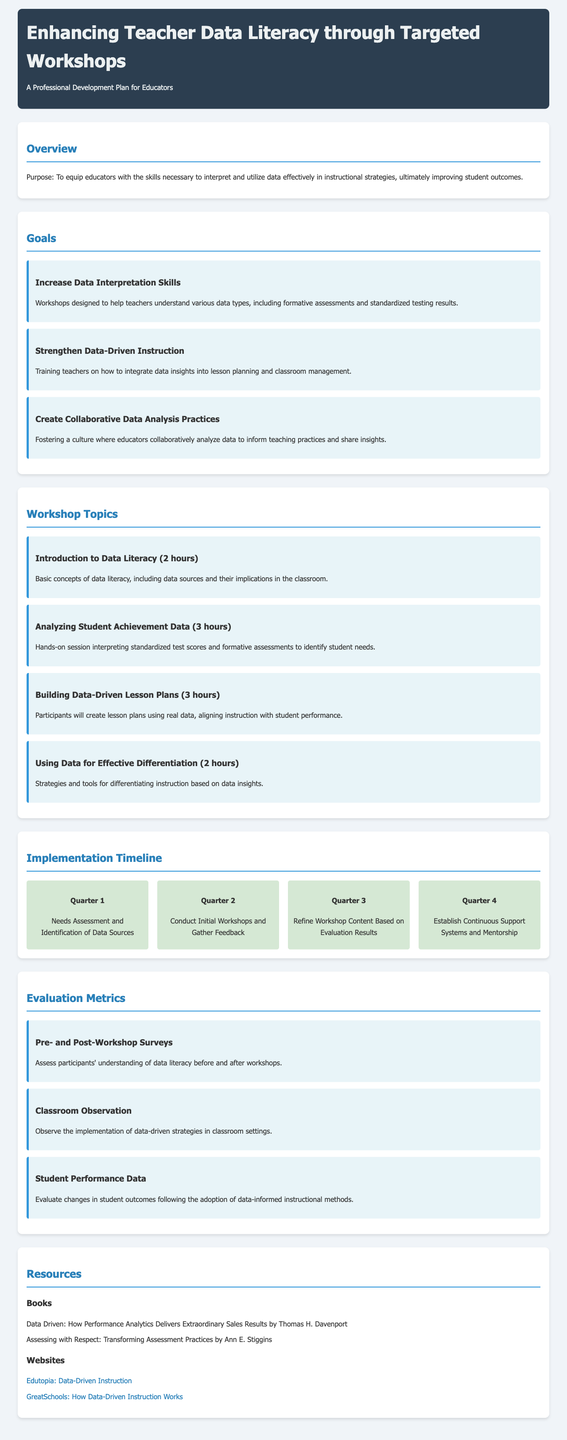What is the purpose of the manual? The purpose is to equip educators with the skills necessary to interpret and utilize data effectively in instructional strategies, ultimately improving student outcomes.
Answer: To equip educators with data skills How many hours is the "Analyzing Student Achievement Data" workshop? The workshop duration is specified in the document, with "Analyzing Student Achievement Data" listed for 3 hours.
Answer: 3 hours What is one goal related to data-driven instruction? The document mentions "Strengthen Data-Driven Instruction" as a goal including integrating data insights into lesson planning and classroom management.
Answer: Strengthen Data-Driven Instruction In which quarter is the initial workshops conducted? The document outlines the implementation timeline, stating initial workshops take place in Quarter 2.
Answer: Quarter 2 What evaluation metric assesses understanding before and after workshops? The document specifies "Pre- and Post-Workshop Surveys" as a method for assessing understanding.
Answer: Pre- and Post-Workshop Surveys Which resource is a book mentioned in the manual? The document lists relevant books, including "Data Driven: How Performance Analytics Delivers Extraordinary Sales Results."
Answer: Data Driven: How Performance Analytics Delivers Extraordinary Sales Results What is the focus of the "Using Data for Effective Differentiation" workshop? The workshop focuses on strategies and tools for differentiating instruction based on data insights.
Answer: Differentiating instruction based on data insights What type of document is this? The document is designed as a manual for enhancing teacher data literacy through targeted workshops.
Answer: A manual for enhancing teacher data literacy 